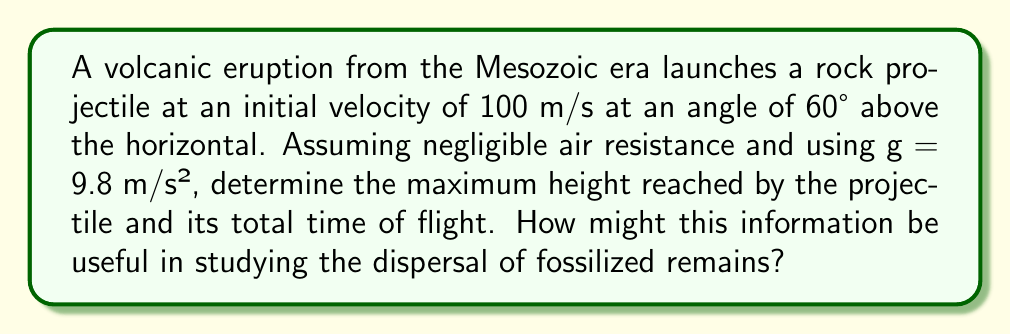Help me with this question. Let's approach this step-by-step:

1) First, we need to decompose the initial velocity into its vertical and horizontal components:

   $v_{0x} = v_0 \cos \theta = 100 \cos 60° = 50$ m/s
   $v_{0y} = v_0 \sin \theta = 100 \sin 60° = 86.6$ m/s

2) To find the maximum height, we use the equation:

   $h_{max} = \frac{v_{0y}^2}{2g}$

   Substituting our values:
   $h_{max} = \frac{(86.6)^2}{2(9.8)} = 382.65$ m

3) For the total time of flight, we need to calculate the time to reach the maximum height and double it:

   $t_{up} = \frac{v_{0y}}{g} = \frac{86.6}{9.8} = 8.84$ s

   Total time = $2t_{up} = 2(8.84) = 17.68$ s

4) As an aspiring paleontologist, this information could be crucial in understanding the distribution of fossilized remains from volcanic events. The maximum height and time of flight can help determine the potential area where fossils might be found, aiding in excavation planning and site selection for fossil hunting.

[asy]
import graph;
size(200,150);
real f(real x) {return -0.0098*x^2 + 1.732*x;}
draw(graph(f,0,176.8), red);
draw((0,0)--(176.8,0), arrow=Arrow);
draw((0,0)--(0,400), arrow=Arrow);
label("Distance (m)", (176.8,0), E);
label("Height (m)", (0,400), N);
dot((88.4,382.65));
label("Max Height", (88.4,382.65), NE);
[/asy]
Answer: Maximum height: 382.65 m; Total flight time: 17.68 s 